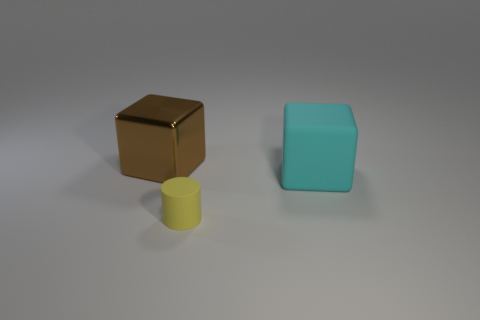Is there any other thing that is the same size as the yellow matte cylinder?
Provide a short and direct response. No. How many other big matte objects are the same shape as the large cyan rubber thing?
Make the answer very short. 0. Is the number of yellow rubber cylinders that are to the left of the tiny cylinder the same as the number of metal cubes behind the big matte block?
Give a very brief answer. No. Are any large brown shiny blocks visible?
Ensure brevity in your answer.  Yes. What size is the metallic object left of the matte thing that is on the right side of the rubber thing in front of the cyan matte cube?
Offer a very short reply. Large. What shape is the other thing that is the same size as the cyan thing?
Provide a short and direct response. Cube. Are there any other things that have the same material as the big cyan thing?
Ensure brevity in your answer.  Yes. How many things are big blocks that are on the left side of the cyan thing or tiny gray cylinders?
Provide a short and direct response. 1. Is there a matte cube that is behind the large block left of the big object that is on the right side of the small rubber cylinder?
Your answer should be very brief. No. What number of small brown metallic cylinders are there?
Provide a succinct answer. 0. 